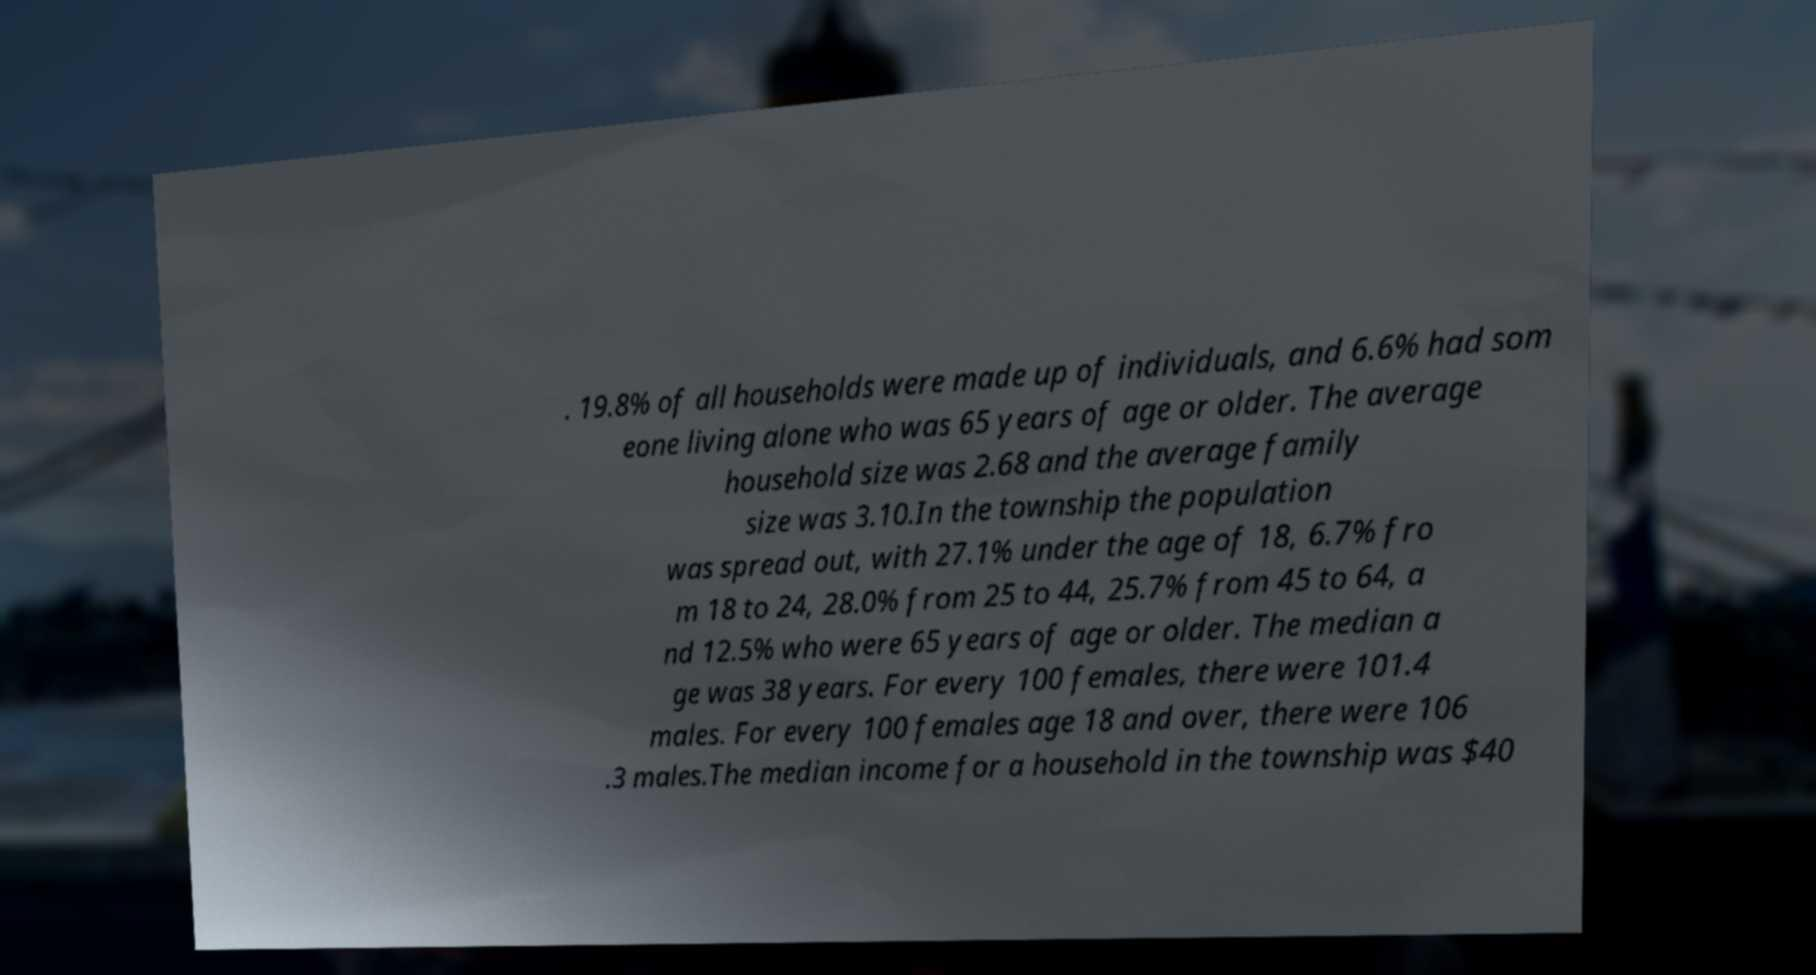Please identify and transcribe the text found in this image. . 19.8% of all households were made up of individuals, and 6.6% had som eone living alone who was 65 years of age or older. The average household size was 2.68 and the average family size was 3.10.In the township the population was spread out, with 27.1% under the age of 18, 6.7% fro m 18 to 24, 28.0% from 25 to 44, 25.7% from 45 to 64, a nd 12.5% who were 65 years of age or older. The median a ge was 38 years. For every 100 females, there were 101.4 males. For every 100 females age 18 and over, there were 106 .3 males.The median income for a household in the township was $40 